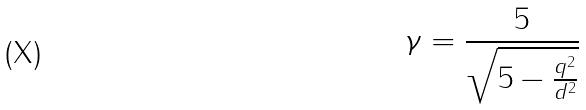Convert formula to latex. <formula><loc_0><loc_0><loc_500><loc_500>\gamma = \frac { 5 } { \sqrt { 5 - \frac { q ^ { 2 } } { d ^ { 2 } } } }</formula> 